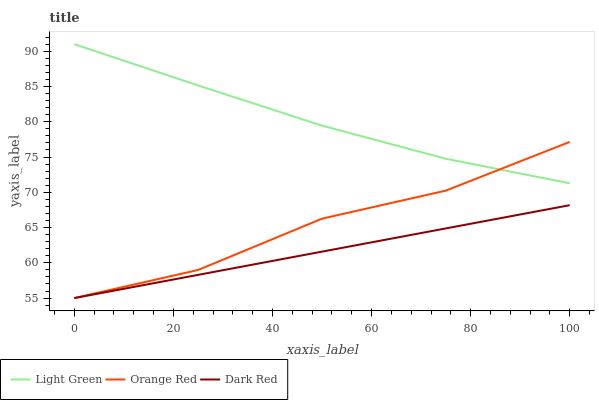Does Dark Red have the minimum area under the curve?
Answer yes or no. Yes. Does Light Green have the maximum area under the curve?
Answer yes or no. Yes. Does Orange Red have the minimum area under the curve?
Answer yes or no. No. Does Orange Red have the maximum area under the curve?
Answer yes or no. No. Is Dark Red the smoothest?
Answer yes or no. Yes. Is Orange Red the roughest?
Answer yes or no. Yes. Is Light Green the smoothest?
Answer yes or no. No. Is Light Green the roughest?
Answer yes or no. No. Does Dark Red have the lowest value?
Answer yes or no. Yes. Does Light Green have the lowest value?
Answer yes or no. No. Does Light Green have the highest value?
Answer yes or no. Yes. Does Orange Red have the highest value?
Answer yes or no. No. Is Dark Red less than Light Green?
Answer yes or no. Yes. Is Light Green greater than Dark Red?
Answer yes or no. Yes. Does Light Green intersect Orange Red?
Answer yes or no. Yes. Is Light Green less than Orange Red?
Answer yes or no. No. Is Light Green greater than Orange Red?
Answer yes or no. No. Does Dark Red intersect Light Green?
Answer yes or no. No. 